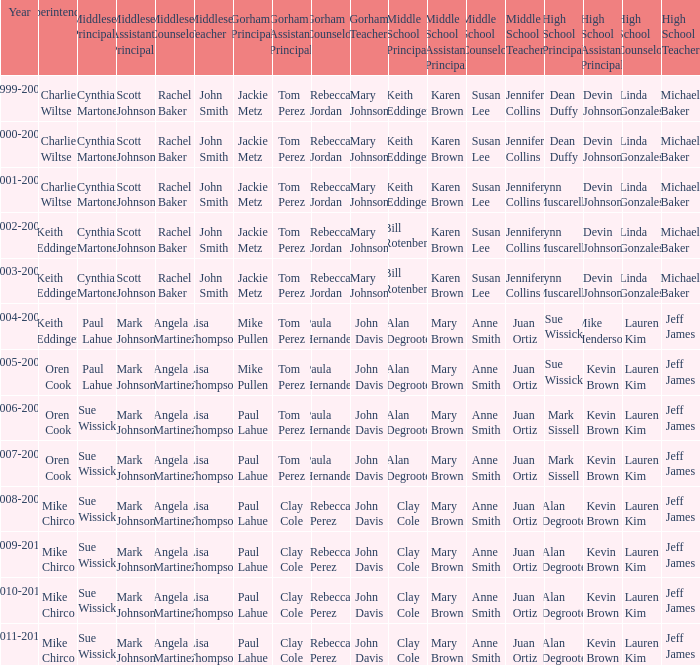How many middlesex principals were there in 2000-2001? 1.0. 